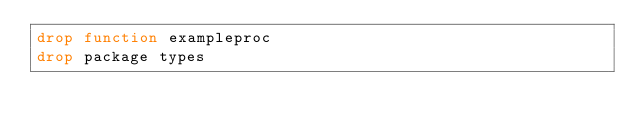Convert code to text. <code><loc_0><loc_0><loc_500><loc_500><_SQL_>drop function exampleproc
drop package types
</code> 